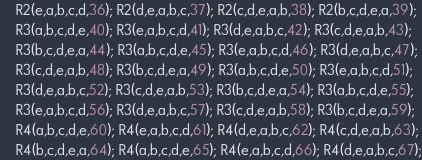<code> <loc_0><loc_0><loc_500><loc_500><_C_>    R2(e,a,b,c,d,36); R2(d,e,a,b,c,37); R2(c,d,e,a,b,38); R2(b,c,d,e,a,39);
    R3(a,b,c,d,e,40); R3(e,a,b,c,d,41); R3(d,e,a,b,c,42); R3(c,d,e,a,b,43);
    R3(b,c,d,e,a,44); R3(a,b,c,d,e,45); R3(e,a,b,c,d,46); R3(d,e,a,b,c,47);
    R3(c,d,e,a,b,48); R3(b,c,d,e,a,49); R3(a,b,c,d,e,50); R3(e,a,b,c,d,51);
    R3(d,e,a,b,c,52); R3(c,d,e,a,b,53); R3(b,c,d,e,a,54); R3(a,b,c,d,e,55);
    R3(e,a,b,c,d,56); R3(d,e,a,b,c,57); R3(c,d,e,a,b,58); R3(b,c,d,e,a,59);
    R4(a,b,c,d,e,60); R4(e,a,b,c,d,61); R4(d,e,a,b,c,62); R4(c,d,e,a,b,63);
    R4(b,c,d,e,a,64); R4(a,b,c,d,e,65); R4(e,a,b,c,d,66); R4(d,e,a,b,c,67);</code> 